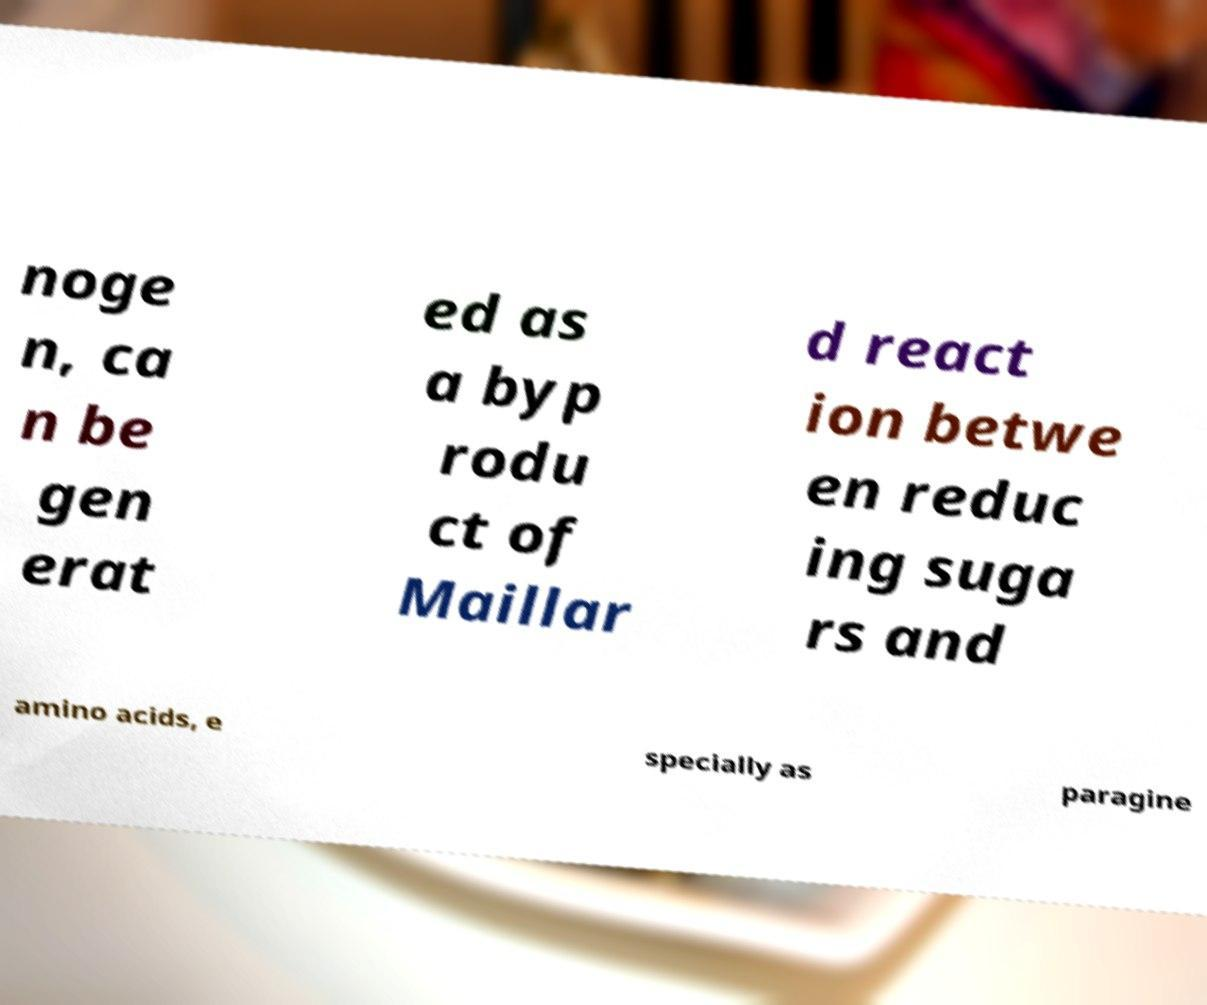Please read and relay the text visible in this image. What does it say? noge n, ca n be gen erat ed as a byp rodu ct of Maillar d react ion betwe en reduc ing suga rs and amino acids, e specially as paragine 